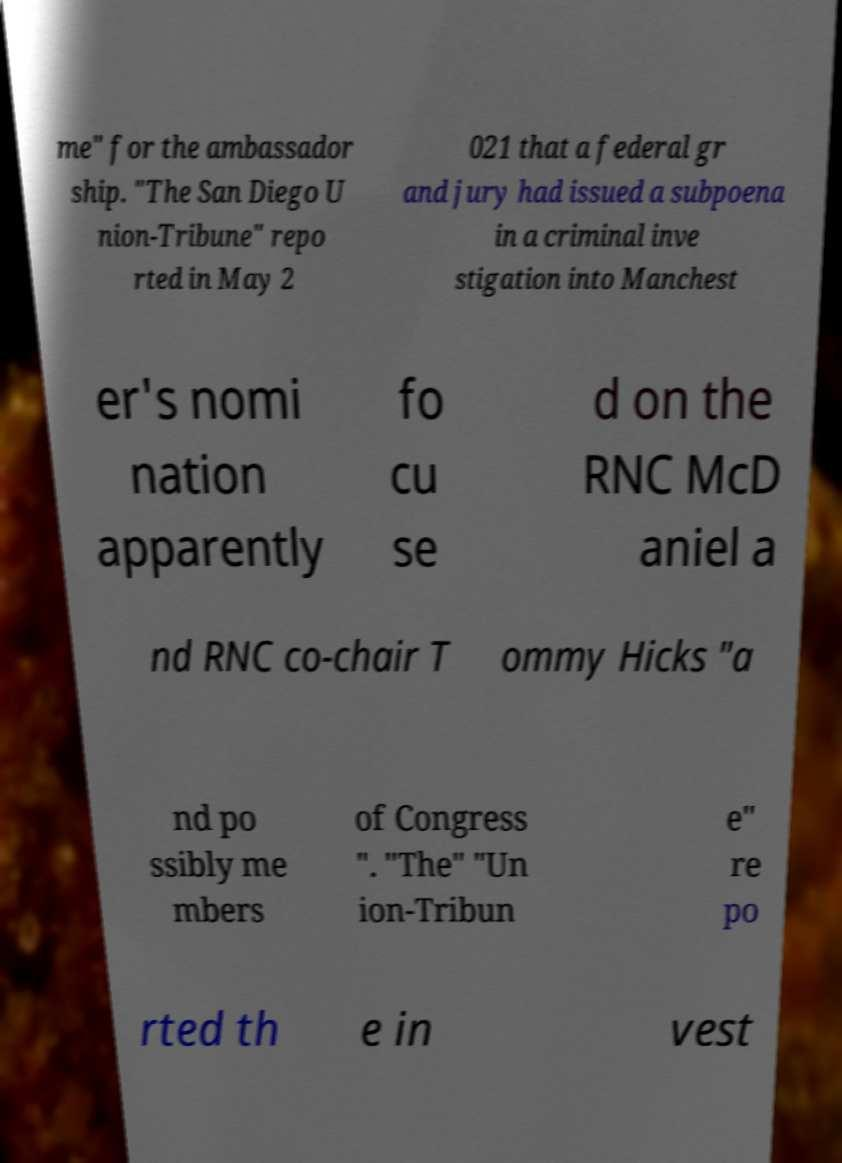Please read and relay the text visible in this image. What does it say? me" for the ambassador ship. "The San Diego U nion-Tribune" repo rted in May 2 021 that a federal gr and jury had issued a subpoena in a criminal inve stigation into Manchest er's nomi nation apparently fo cu se d on the RNC McD aniel a nd RNC co-chair T ommy Hicks "a nd po ssibly me mbers of Congress ". "The" "Un ion-Tribun e" re po rted th e in vest 